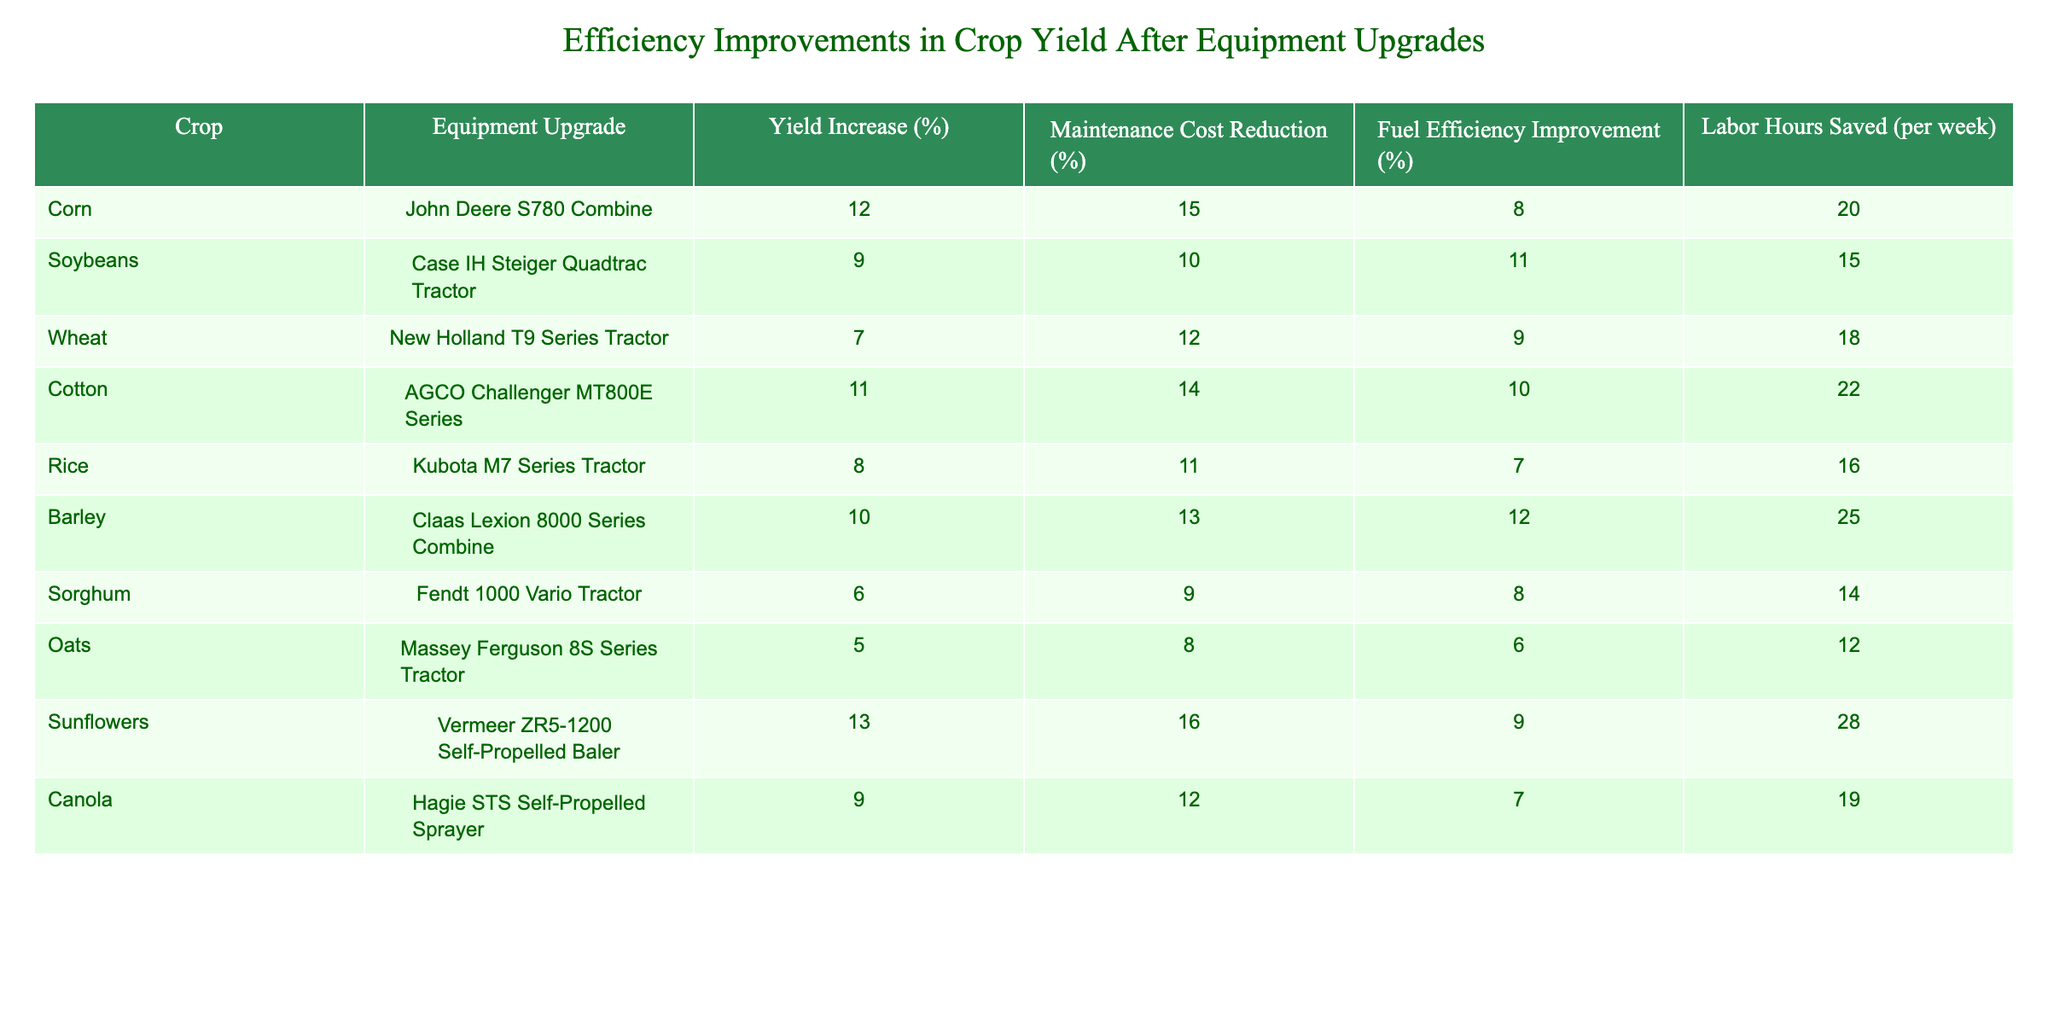What is the yield increase percentage for corn after the equipment upgrade? The table indicates that the yield increase percentage for corn after upgrading to the John Deere S780 Combine is 12%.
Answer: 12% Which equipment upgrade results in the highest maintenance cost reduction? By examining the maintenance cost reduction percentages, the AGCO Challenger MT800E Series shows a reduction of 14%, which is the highest among all options listed.
Answer: AGCO Challenger MT800E Series What is the fuel efficiency improvement for the New Holland T9 Series Tractor? The table shows that the New Holland T9 Series Tractor has a fuel efficiency improvement of 9%.
Answer: 9% If we consider the labor hours saved, which crop leads with the highest value? From the table, the AGCO Challenger MT800E Series saves 22 labor hours per week, which is the highest value for labor hours saved among all crops.
Answer: 22 What is the average yield increase percentage across all equipment upgrades? The yield increase percentages can be summed up: (12 + 9 + 7 + 11 + 8 + 10 + 6 + 5 + 13 + 9) = 90. There are 10 crops, so the average is 90 / 10 = 9.
Answer: 9 Are there any equipment upgrades with a yield increase of 10% or more? Yes, the table shows three equipment upgrades (John Deere S780 Combine, AGCO Challenger MT800E Series, and Vermeer ZR5-1200 Self-Propelled Baler) with yield increases of 10% or more.
Answer: Yes Which crop had the lowest fuel efficiency improvement? The table indicates that the Kubota M7 Series Tractor for rice has the lowest fuel efficiency improvement of 7%.
Answer: 7% What is the total maintenance cost reduction percentage for all the crops listed? If we sum up the maintenance cost reductions: (15 + 10 + 12 + 14 + 11 + 13 + 9 + 8 + 16 + 12) = 120. This value represents the total percentage of maintenance cost reduction across all crops.
Answer: 120 Which crop provides both the highest yield increase and the highest labor hours saved? The crop that achieves both high yield increase and high labor hours saved is sunflowers, with 13% yield increase and 28 hours saved per week.
Answer: Sunflowers If we consider only the top three crops by yield increase, what is their average labor hours saved? The top three crops by yield increase are: Sunflowers (28 hours), Corn (20 hours), and AGCO Challenger MT800E Series (22 hours). The total labor hours saved for these top three is 28 + 20 + 22 = 70 hours. Therefore, the average is 70 / 3 = approximately 23.33.
Answer: 23.33 